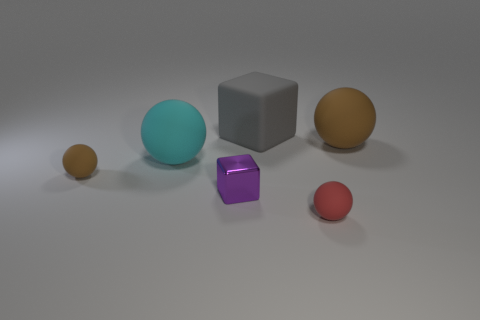Subtract all purple balls. Subtract all cyan blocks. How many balls are left? 4 Add 2 matte objects. How many objects exist? 8 Subtract all balls. How many objects are left? 2 Subtract all gray balls. Subtract all brown matte spheres. How many objects are left? 4 Add 5 tiny purple things. How many tiny purple things are left? 6 Add 6 large blue matte spheres. How many large blue matte spheres exist? 6 Subtract 1 gray blocks. How many objects are left? 5 